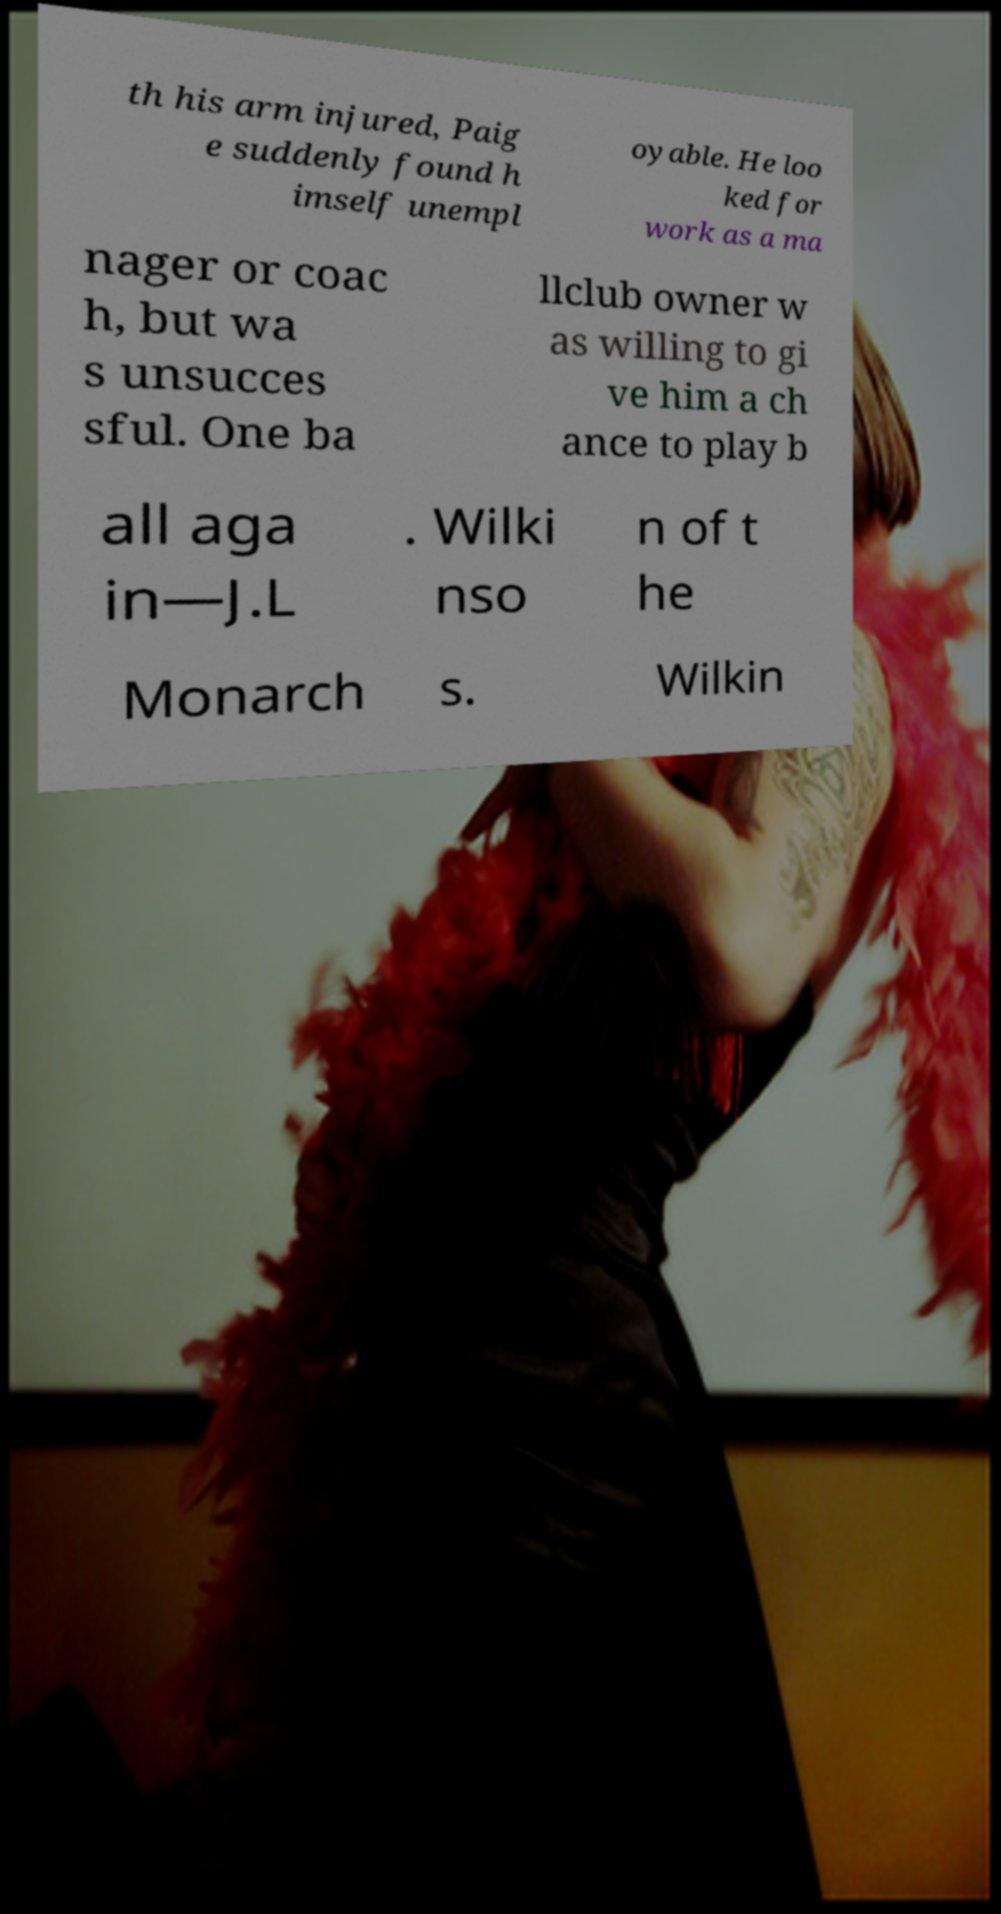Could you extract and type out the text from this image? th his arm injured, Paig e suddenly found h imself unempl oyable. He loo ked for work as a ma nager or coac h, but wa s unsucces sful. One ba llclub owner w as willing to gi ve him a ch ance to play b all aga in—J.L . Wilki nso n of t he Monarch s. Wilkin 